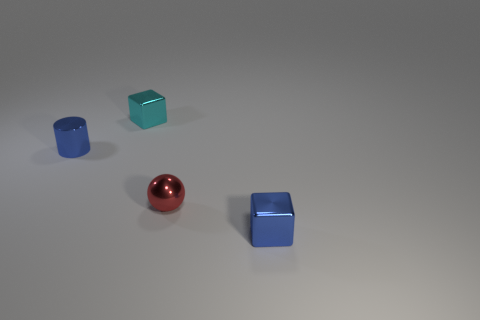What shape is the blue thing that is behind the red metallic sphere?
Your answer should be very brief. Cylinder. What number of blue metallic things have the same shape as the tiny cyan object?
Your response must be concise. 1. Are there the same number of blue shiny objects to the right of the small cyan thing and cyan metal cubes that are on the right side of the small red thing?
Provide a short and direct response. No. Are there any tiny blocks made of the same material as the red ball?
Provide a succinct answer. Yes. Is the material of the blue block the same as the cylinder?
Ensure brevity in your answer.  Yes. What number of blue things are either cylinders or small shiny spheres?
Offer a terse response. 1. Are there more shiny balls behind the cyan object than tiny red shiny objects?
Make the answer very short. No. Is there a small object that has the same color as the tiny shiny cylinder?
Provide a short and direct response. Yes. What is the size of the cyan thing?
Provide a succinct answer. Small. Do the small cylinder and the sphere have the same color?
Offer a terse response. No. 